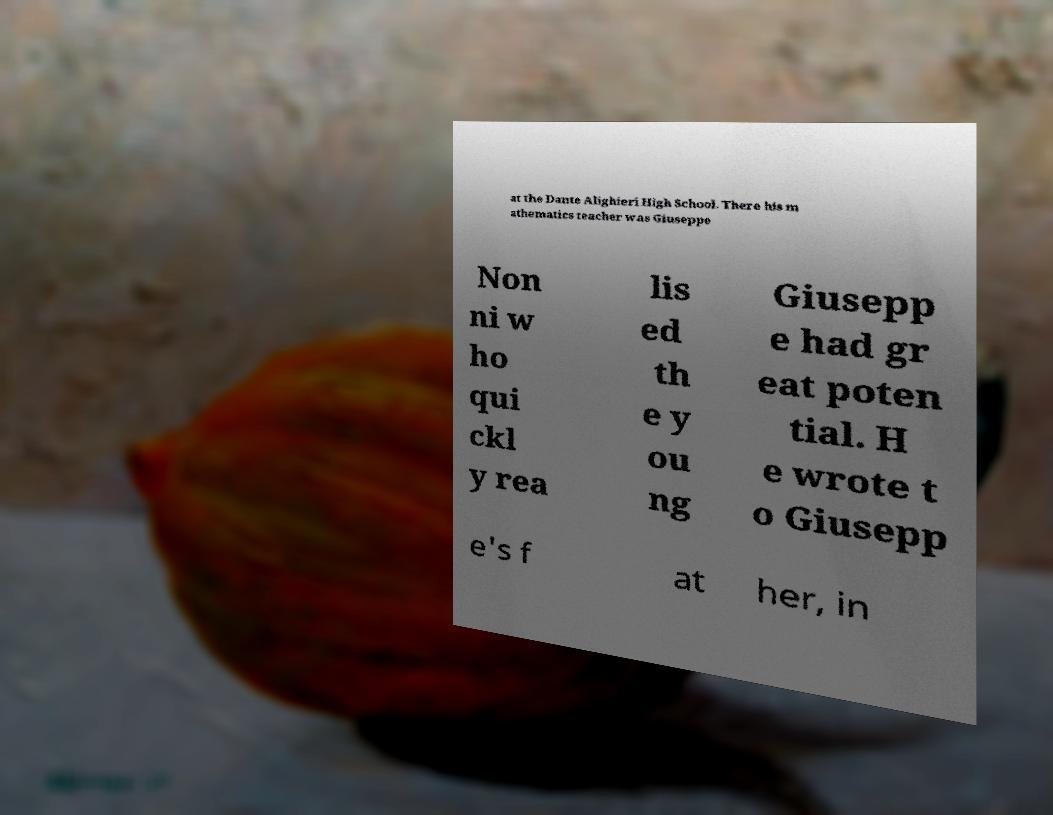Please read and relay the text visible in this image. What does it say? at the Dante Alighieri High School. There his m athematics teacher was Giuseppe Non ni w ho qui ckl y rea lis ed th e y ou ng Giusepp e had gr eat poten tial. H e wrote t o Giusepp e's f at her, in 